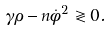Convert formula to latex. <formula><loc_0><loc_0><loc_500><loc_500>\gamma \rho - n \dot { \phi } ^ { 2 } \gtrless 0 .</formula> 